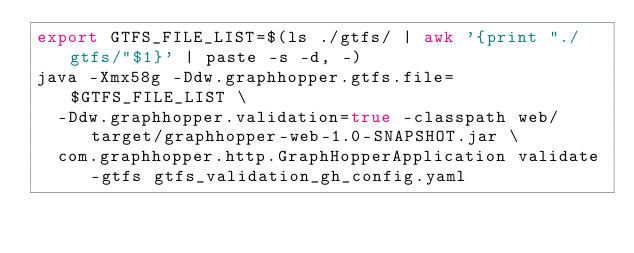Convert code to text. <code><loc_0><loc_0><loc_500><loc_500><_Bash_>export GTFS_FILE_LIST=$(ls ./gtfs/ | awk '{print "./gtfs/"$1}' | paste -s -d, -)
java -Xmx58g -Ddw.graphhopper.gtfs.file=$GTFS_FILE_LIST \
  -Ddw.graphhopper.validation=true -classpath web/target/graphhopper-web-1.0-SNAPSHOT.jar \
  com.graphhopper.http.GraphHopperApplication validate-gtfs gtfs_validation_gh_config.yaml
</code> 